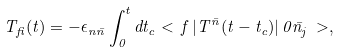Convert formula to latex. <formula><loc_0><loc_0><loc_500><loc_500>T _ { f i } ( t ) = - \epsilon _ { n \bar { n } } \int _ { 0 } ^ { t } d t _ { c } < \, f \, | T ^ { \bar { n } } ( t - t _ { c } ) | \, 0 \bar { n } _ { j } \, > ,</formula> 